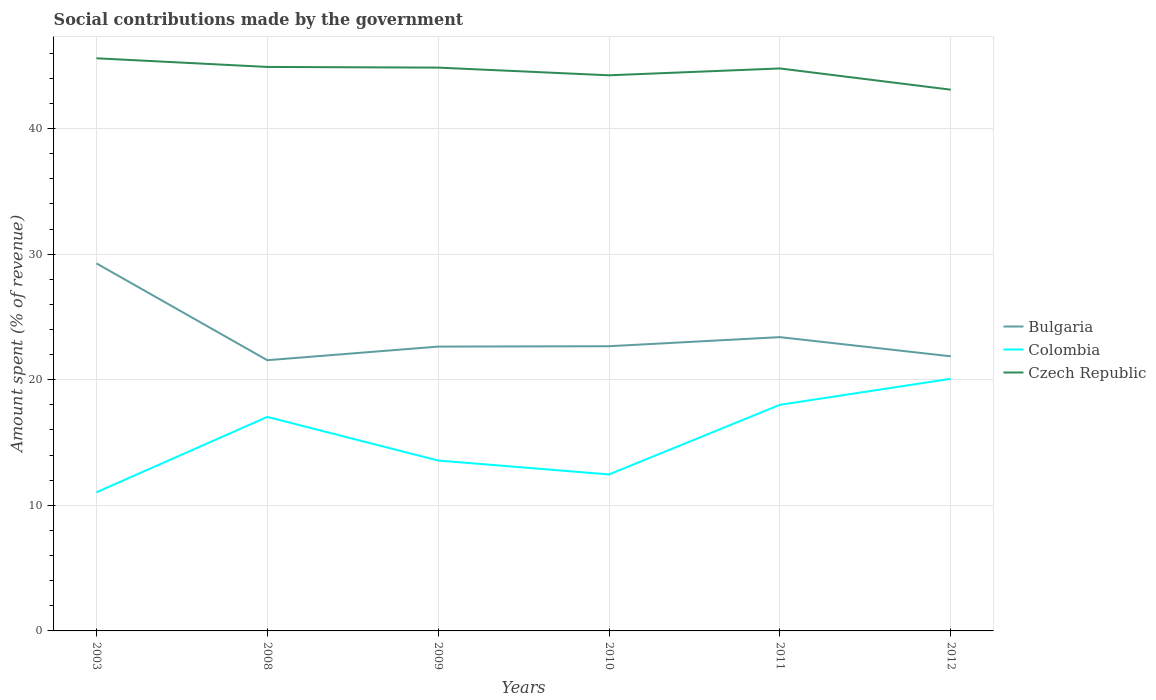Is the number of lines equal to the number of legend labels?
Give a very brief answer. Yes. Across all years, what is the maximum amount spent (in %) on social contributions in Bulgaria?
Keep it short and to the point. 21.56. What is the total amount spent (in %) on social contributions in Czech Republic in the graph?
Your answer should be very brief. 0.07. What is the difference between the highest and the second highest amount spent (in %) on social contributions in Colombia?
Provide a short and direct response. 9.04. What is the difference between the highest and the lowest amount spent (in %) on social contributions in Colombia?
Offer a very short reply. 3. What is the difference between two consecutive major ticks on the Y-axis?
Your response must be concise. 10. Where does the legend appear in the graph?
Provide a succinct answer. Center right. What is the title of the graph?
Your answer should be compact. Social contributions made by the government. What is the label or title of the X-axis?
Offer a terse response. Years. What is the label or title of the Y-axis?
Provide a succinct answer. Amount spent (% of revenue). What is the Amount spent (% of revenue) in Bulgaria in 2003?
Keep it short and to the point. 29.27. What is the Amount spent (% of revenue) in Colombia in 2003?
Keep it short and to the point. 11.04. What is the Amount spent (% of revenue) in Czech Republic in 2003?
Offer a terse response. 45.6. What is the Amount spent (% of revenue) in Bulgaria in 2008?
Provide a succinct answer. 21.56. What is the Amount spent (% of revenue) of Colombia in 2008?
Ensure brevity in your answer.  17.04. What is the Amount spent (% of revenue) of Czech Republic in 2008?
Offer a terse response. 44.91. What is the Amount spent (% of revenue) in Bulgaria in 2009?
Your response must be concise. 22.64. What is the Amount spent (% of revenue) in Colombia in 2009?
Your answer should be very brief. 13.57. What is the Amount spent (% of revenue) in Czech Republic in 2009?
Offer a terse response. 44.85. What is the Amount spent (% of revenue) of Bulgaria in 2010?
Your answer should be compact. 22.67. What is the Amount spent (% of revenue) of Colombia in 2010?
Ensure brevity in your answer.  12.46. What is the Amount spent (% of revenue) in Czech Republic in 2010?
Offer a very short reply. 44.24. What is the Amount spent (% of revenue) of Bulgaria in 2011?
Make the answer very short. 23.39. What is the Amount spent (% of revenue) of Colombia in 2011?
Provide a succinct answer. 18. What is the Amount spent (% of revenue) of Czech Republic in 2011?
Keep it short and to the point. 44.79. What is the Amount spent (% of revenue) in Bulgaria in 2012?
Offer a terse response. 21.87. What is the Amount spent (% of revenue) of Colombia in 2012?
Give a very brief answer. 20.08. What is the Amount spent (% of revenue) of Czech Republic in 2012?
Give a very brief answer. 43.1. Across all years, what is the maximum Amount spent (% of revenue) in Bulgaria?
Provide a short and direct response. 29.27. Across all years, what is the maximum Amount spent (% of revenue) of Colombia?
Your response must be concise. 20.08. Across all years, what is the maximum Amount spent (% of revenue) in Czech Republic?
Give a very brief answer. 45.6. Across all years, what is the minimum Amount spent (% of revenue) in Bulgaria?
Make the answer very short. 21.56. Across all years, what is the minimum Amount spent (% of revenue) of Colombia?
Offer a very short reply. 11.04. Across all years, what is the minimum Amount spent (% of revenue) of Czech Republic?
Make the answer very short. 43.1. What is the total Amount spent (% of revenue) in Bulgaria in the graph?
Your answer should be very brief. 141.39. What is the total Amount spent (% of revenue) of Colombia in the graph?
Your answer should be compact. 92.18. What is the total Amount spent (% of revenue) in Czech Republic in the graph?
Your answer should be very brief. 267.47. What is the difference between the Amount spent (% of revenue) of Bulgaria in 2003 and that in 2008?
Provide a short and direct response. 7.71. What is the difference between the Amount spent (% of revenue) of Colombia in 2003 and that in 2008?
Your answer should be very brief. -6. What is the difference between the Amount spent (% of revenue) of Czech Republic in 2003 and that in 2008?
Give a very brief answer. 0.69. What is the difference between the Amount spent (% of revenue) in Bulgaria in 2003 and that in 2009?
Offer a very short reply. 6.63. What is the difference between the Amount spent (% of revenue) in Colombia in 2003 and that in 2009?
Ensure brevity in your answer.  -2.53. What is the difference between the Amount spent (% of revenue) in Czech Republic in 2003 and that in 2009?
Your response must be concise. 0.74. What is the difference between the Amount spent (% of revenue) in Bulgaria in 2003 and that in 2010?
Keep it short and to the point. 6.6. What is the difference between the Amount spent (% of revenue) in Colombia in 2003 and that in 2010?
Your response must be concise. -1.42. What is the difference between the Amount spent (% of revenue) in Czech Republic in 2003 and that in 2010?
Make the answer very short. 1.35. What is the difference between the Amount spent (% of revenue) in Bulgaria in 2003 and that in 2011?
Offer a very short reply. 5.87. What is the difference between the Amount spent (% of revenue) of Colombia in 2003 and that in 2011?
Provide a short and direct response. -6.97. What is the difference between the Amount spent (% of revenue) of Czech Republic in 2003 and that in 2011?
Your response must be concise. 0.81. What is the difference between the Amount spent (% of revenue) in Bulgaria in 2003 and that in 2012?
Your answer should be very brief. 7.4. What is the difference between the Amount spent (% of revenue) in Colombia in 2003 and that in 2012?
Give a very brief answer. -9.04. What is the difference between the Amount spent (% of revenue) in Czech Republic in 2003 and that in 2012?
Your answer should be very brief. 2.5. What is the difference between the Amount spent (% of revenue) in Bulgaria in 2008 and that in 2009?
Keep it short and to the point. -1.08. What is the difference between the Amount spent (% of revenue) of Colombia in 2008 and that in 2009?
Ensure brevity in your answer.  3.47. What is the difference between the Amount spent (% of revenue) of Czech Republic in 2008 and that in 2009?
Your answer should be very brief. 0.05. What is the difference between the Amount spent (% of revenue) in Bulgaria in 2008 and that in 2010?
Provide a succinct answer. -1.11. What is the difference between the Amount spent (% of revenue) in Colombia in 2008 and that in 2010?
Provide a succinct answer. 4.58. What is the difference between the Amount spent (% of revenue) in Czech Republic in 2008 and that in 2010?
Offer a terse response. 0.67. What is the difference between the Amount spent (% of revenue) in Bulgaria in 2008 and that in 2011?
Provide a short and direct response. -1.84. What is the difference between the Amount spent (% of revenue) of Colombia in 2008 and that in 2011?
Provide a succinct answer. -0.96. What is the difference between the Amount spent (% of revenue) of Czech Republic in 2008 and that in 2011?
Offer a terse response. 0.12. What is the difference between the Amount spent (% of revenue) of Bulgaria in 2008 and that in 2012?
Offer a very short reply. -0.31. What is the difference between the Amount spent (% of revenue) of Colombia in 2008 and that in 2012?
Provide a succinct answer. -3.04. What is the difference between the Amount spent (% of revenue) of Czech Republic in 2008 and that in 2012?
Give a very brief answer. 1.81. What is the difference between the Amount spent (% of revenue) in Bulgaria in 2009 and that in 2010?
Provide a succinct answer. -0.03. What is the difference between the Amount spent (% of revenue) in Colombia in 2009 and that in 2010?
Make the answer very short. 1.11. What is the difference between the Amount spent (% of revenue) in Czech Republic in 2009 and that in 2010?
Give a very brief answer. 0.61. What is the difference between the Amount spent (% of revenue) in Bulgaria in 2009 and that in 2011?
Offer a very short reply. -0.75. What is the difference between the Amount spent (% of revenue) of Colombia in 2009 and that in 2011?
Offer a very short reply. -4.44. What is the difference between the Amount spent (% of revenue) of Czech Republic in 2009 and that in 2011?
Offer a terse response. 0.07. What is the difference between the Amount spent (% of revenue) in Bulgaria in 2009 and that in 2012?
Your answer should be very brief. 0.77. What is the difference between the Amount spent (% of revenue) in Colombia in 2009 and that in 2012?
Keep it short and to the point. -6.51. What is the difference between the Amount spent (% of revenue) of Czech Republic in 2009 and that in 2012?
Keep it short and to the point. 1.76. What is the difference between the Amount spent (% of revenue) in Bulgaria in 2010 and that in 2011?
Keep it short and to the point. -0.72. What is the difference between the Amount spent (% of revenue) in Colombia in 2010 and that in 2011?
Your response must be concise. -5.54. What is the difference between the Amount spent (% of revenue) in Czech Republic in 2010 and that in 2011?
Ensure brevity in your answer.  -0.54. What is the difference between the Amount spent (% of revenue) of Bulgaria in 2010 and that in 2012?
Provide a succinct answer. 0.8. What is the difference between the Amount spent (% of revenue) of Colombia in 2010 and that in 2012?
Provide a short and direct response. -7.62. What is the difference between the Amount spent (% of revenue) of Czech Republic in 2010 and that in 2012?
Keep it short and to the point. 1.15. What is the difference between the Amount spent (% of revenue) of Bulgaria in 2011 and that in 2012?
Offer a very short reply. 1.53. What is the difference between the Amount spent (% of revenue) in Colombia in 2011 and that in 2012?
Give a very brief answer. -2.07. What is the difference between the Amount spent (% of revenue) in Czech Republic in 2011 and that in 2012?
Offer a very short reply. 1.69. What is the difference between the Amount spent (% of revenue) in Bulgaria in 2003 and the Amount spent (% of revenue) in Colombia in 2008?
Provide a short and direct response. 12.23. What is the difference between the Amount spent (% of revenue) of Bulgaria in 2003 and the Amount spent (% of revenue) of Czech Republic in 2008?
Your response must be concise. -15.64. What is the difference between the Amount spent (% of revenue) of Colombia in 2003 and the Amount spent (% of revenue) of Czech Republic in 2008?
Give a very brief answer. -33.87. What is the difference between the Amount spent (% of revenue) in Bulgaria in 2003 and the Amount spent (% of revenue) in Colombia in 2009?
Offer a terse response. 15.7. What is the difference between the Amount spent (% of revenue) in Bulgaria in 2003 and the Amount spent (% of revenue) in Czech Republic in 2009?
Provide a short and direct response. -15.59. What is the difference between the Amount spent (% of revenue) of Colombia in 2003 and the Amount spent (% of revenue) of Czech Republic in 2009?
Provide a short and direct response. -33.82. What is the difference between the Amount spent (% of revenue) in Bulgaria in 2003 and the Amount spent (% of revenue) in Colombia in 2010?
Provide a short and direct response. 16.81. What is the difference between the Amount spent (% of revenue) in Bulgaria in 2003 and the Amount spent (% of revenue) in Czech Republic in 2010?
Your response must be concise. -14.97. What is the difference between the Amount spent (% of revenue) in Colombia in 2003 and the Amount spent (% of revenue) in Czech Republic in 2010?
Ensure brevity in your answer.  -33.21. What is the difference between the Amount spent (% of revenue) of Bulgaria in 2003 and the Amount spent (% of revenue) of Colombia in 2011?
Offer a terse response. 11.26. What is the difference between the Amount spent (% of revenue) of Bulgaria in 2003 and the Amount spent (% of revenue) of Czech Republic in 2011?
Give a very brief answer. -15.52. What is the difference between the Amount spent (% of revenue) of Colombia in 2003 and the Amount spent (% of revenue) of Czech Republic in 2011?
Offer a very short reply. -33.75. What is the difference between the Amount spent (% of revenue) in Bulgaria in 2003 and the Amount spent (% of revenue) in Colombia in 2012?
Make the answer very short. 9.19. What is the difference between the Amount spent (% of revenue) in Bulgaria in 2003 and the Amount spent (% of revenue) in Czech Republic in 2012?
Offer a terse response. -13.83. What is the difference between the Amount spent (% of revenue) of Colombia in 2003 and the Amount spent (% of revenue) of Czech Republic in 2012?
Provide a succinct answer. -32.06. What is the difference between the Amount spent (% of revenue) in Bulgaria in 2008 and the Amount spent (% of revenue) in Colombia in 2009?
Ensure brevity in your answer.  7.99. What is the difference between the Amount spent (% of revenue) in Bulgaria in 2008 and the Amount spent (% of revenue) in Czech Republic in 2009?
Provide a short and direct response. -23.3. What is the difference between the Amount spent (% of revenue) in Colombia in 2008 and the Amount spent (% of revenue) in Czech Republic in 2009?
Offer a terse response. -27.81. What is the difference between the Amount spent (% of revenue) in Bulgaria in 2008 and the Amount spent (% of revenue) in Colombia in 2010?
Keep it short and to the point. 9.1. What is the difference between the Amount spent (% of revenue) of Bulgaria in 2008 and the Amount spent (% of revenue) of Czech Republic in 2010?
Your response must be concise. -22.69. What is the difference between the Amount spent (% of revenue) in Colombia in 2008 and the Amount spent (% of revenue) in Czech Republic in 2010?
Provide a succinct answer. -27.2. What is the difference between the Amount spent (% of revenue) of Bulgaria in 2008 and the Amount spent (% of revenue) of Colombia in 2011?
Offer a terse response. 3.55. What is the difference between the Amount spent (% of revenue) of Bulgaria in 2008 and the Amount spent (% of revenue) of Czech Republic in 2011?
Your answer should be compact. -23.23. What is the difference between the Amount spent (% of revenue) in Colombia in 2008 and the Amount spent (% of revenue) in Czech Republic in 2011?
Provide a succinct answer. -27.75. What is the difference between the Amount spent (% of revenue) of Bulgaria in 2008 and the Amount spent (% of revenue) of Colombia in 2012?
Make the answer very short. 1.48. What is the difference between the Amount spent (% of revenue) in Bulgaria in 2008 and the Amount spent (% of revenue) in Czech Republic in 2012?
Give a very brief answer. -21.54. What is the difference between the Amount spent (% of revenue) of Colombia in 2008 and the Amount spent (% of revenue) of Czech Republic in 2012?
Your response must be concise. -26.06. What is the difference between the Amount spent (% of revenue) in Bulgaria in 2009 and the Amount spent (% of revenue) in Colombia in 2010?
Your answer should be very brief. 10.18. What is the difference between the Amount spent (% of revenue) in Bulgaria in 2009 and the Amount spent (% of revenue) in Czech Republic in 2010?
Your answer should be very brief. -21.6. What is the difference between the Amount spent (% of revenue) in Colombia in 2009 and the Amount spent (% of revenue) in Czech Republic in 2010?
Your answer should be very brief. -30.67. What is the difference between the Amount spent (% of revenue) of Bulgaria in 2009 and the Amount spent (% of revenue) of Colombia in 2011?
Offer a very short reply. 4.64. What is the difference between the Amount spent (% of revenue) of Bulgaria in 2009 and the Amount spent (% of revenue) of Czech Republic in 2011?
Provide a succinct answer. -22.15. What is the difference between the Amount spent (% of revenue) in Colombia in 2009 and the Amount spent (% of revenue) in Czech Republic in 2011?
Your answer should be very brief. -31.22. What is the difference between the Amount spent (% of revenue) in Bulgaria in 2009 and the Amount spent (% of revenue) in Colombia in 2012?
Offer a terse response. 2.56. What is the difference between the Amount spent (% of revenue) of Bulgaria in 2009 and the Amount spent (% of revenue) of Czech Republic in 2012?
Provide a short and direct response. -20.46. What is the difference between the Amount spent (% of revenue) in Colombia in 2009 and the Amount spent (% of revenue) in Czech Republic in 2012?
Make the answer very short. -29.53. What is the difference between the Amount spent (% of revenue) in Bulgaria in 2010 and the Amount spent (% of revenue) in Colombia in 2011?
Your answer should be compact. 4.67. What is the difference between the Amount spent (% of revenue) of Bulgaria in 2010 and the Amount spent (% of revenue) of Czech Republic in 2011?
Ensure brevity in your answer.  -22.12. What is the difference between the Amount spent (% of revenue) in Colombia in 2010 and the Amount spent (% of revenue) in Czech Republic in 2011?
Your answer should be very brief. -32.33. What is the difference between the Amount spent (% of revenue) in Bulgaria in 2010 and the Amount spent (% of revenue) in Colombia in 2012?
Provide a succinct answer. 2.59. What is the difference between the Amount spent (% of revenue) of Bulgaria in 2010 and the Amount spent (% of revenue) of Czech Republic in 2012?
Provide a succinct answer. -20.43. What is the difference between the Amount spent (% of revenue) in Colombia in 2010 and the Amount spent (% of revenue) in Czech Republic in 2012?
Keep it short and to the point. -30.64. What is the difference between the Amount spent (% of revenue) in Bulgaria in 2011 and the Amount spent (% of revenue) in Colombia in 2012?
Offer a terse response. 3.32. What is the difference between the Amount spent (% of revenue) of Bulgaria in 2011 and the Amount spent (% of revenue) of Czech Republic in 2012?
Provide a short and direct response. -19.7. What is the difference between the Amount spent (% of revenue) of Colombia in 2011 and the Amount spent (% of revenue) of Czech Republic in 2012?
Give a very brief answer. -25.09. What is the average Amount spent (% of revenue) of Bulgaria per year?
Offer a very short reply. 23.56. What is the average Amount spent (% of revenue) of Colombia per year?
Give a very brief answer. 15.36. What is the average Amount spent (% of revenue) of Czech Republic per year?
Ensure brevity in your answer.  44.58. In the year 2003, what is the difference between the Amount spent (% of revenue) of Bulgaria and Amount spent (% of revenue) of Colombia?
Provide a short and direct response. 18.23. In the year 2003, what is the difference between the Amount spent (% of revenue) of Bulgaria and Amount spent (% of revenue) of Czech Republic?
Keep it short and to the point. -16.33. In the year 2003, what is the difference between the Amount spent (% of revenue) in Colombia and Amount spent (% of revenue) in Czech Republic?
Keep it short and to the point. -34.56. In the year 2008, what is the difference between the Amount spent (% of revenue) in Bulgaria and Amount spent (% of revenue) in Colombia?
Your answer should be compact. 4.52. In the year 2008, what is the difference between the Amount spent (% of revenue) in Bulgaria and Amount spent (% of revenue) in Czech Republic?
Your answer should be compact. -23.35. In the year 2008, what is the difference between the Amount spent (% of revenue) in Colombia and Amount spent (% of revenue) in Czech Republic?
Ensure brevity in your answer.  -27.87. In the year 2009, what is the difference between the Amount spent (% of revenue) in Bulgaria and Amount spent (% of revenue) in Colombia?
Your answer should be very brief. 9.07. In the year 2009, what is the difference between the Amount spent (% of revenue) in Bulgaria and Amount spent (% of revenue) in Czech Republic?
Your answer should be very brief. -22.21. In the year 2009, what is the difference between the Amount spent (% of revenue) in Colombia and Amount spent (% of revenue) in Czech Republic?
Make the answer very short. -31.29. In the year 2010, what is the difference between the Amount spent (% of revenue) of Bulgaria and Amount spent (% of revenue) of Colombia?
Offer a very short reply. 10.21. In the year 2010, what is the difference between the Amount spent (% of revenue) in Bulgaria and Amount spent (% of revenue) in Czech Republic?
Provide a short and direct response. -21.57. In the year 2010, what is the difference between the Amount spent (% of revenue) of Colombia and Amount spent (% of revenue) of Czech Republic?
Ensure brevity in your answer.  -31.78. In the year 2011, what is the difference between the Amount spent (% of revenue) in Bulgaria and Amount spent (% of revenue) in Colombia?
Offer a very short reply. 5.39. In the year 2011, what is the difference between the Amount spent (% of revenue) in Bulgaria and Amount spent (% of revenue) in Czech Republic?
Your answer should be very brief. -21.39. In the year 2011, what is the difference between the Amount spent (% of revenue) in Colombia and Amount spent (% of revenue) in Czech Republic?
Your answer should be compact. -26.78. In the year 2012, what is the difference between the Amount spent (% of revenue) in Bulgaria and Amount spent (% of revenue) in Colombia?
Ensure brevity in your answer.  1.79. In the year 2012, what is the difference between the Amount spent (% of revenue) of Bulgaria and Amount spent (% of revenue) of Czech Republic?
Your answer should be compact. -21.23. In the year 2012, what is the difference between the Amount spent (% of revenue) of Colombia and Amount spent (% of revenue) of Czech Republic?
Keep it short and to the point. -23.02. What is the ratio of the Amount spent (% of revenue) of Bulgaria in 2003 to that in 2008?
Offer a terse response. 1.36. What is the ratio of the Amount spent (% of revenue) of Colombia in 2003 to that in 2008?
Give a very brief answer. 0.65. What is the ratio of the Amount spent (% of revenue) of Czech Republic in 2003 to that in 2008?
Offer a very short reply. 1.02. What is the ratio of the Amount spent (% of revenue) in Bulgaria in 2003 to that in 2009?
Give a very brief answer. 1.29. What is the ratio of the Amount spent (% of revenue) in Colombia in 2003 to that in 2009?
Your answer should be very brief. 0.81. What is the ratio of the Amount spent (% of revenue) of Czech Republic in 2003 to that in 2009?
Make the answer very short. 1.02. What is the ratio of the Amount spent (% of revenue) in Bulgaria in 2003 to that in 2010?
Your answer should be very brief. 1.29. What is the ratio of the Amount spent (% of revenue) in Colombia in 2003 to that in 2010?
Provide a short and direct response. 0.89. What is the ratio of the Amount spent (% of revenue) of Czech Republic in 2003 to that in 2010?
Your answer should be very brief. 1.03. What is the ratio of the Amount spent (% of revenue) of Bulgaria in 2003 to that in 2011?
Your response must be concise. 1.25. What is the ratio of the Amount spent (% of revenue) of Colombia in 2003 to that in 2011?
Give a very brief answer. 0.61. What is the ratio of the Amount spent (% of revenue) of Czech Republic in 2003 to that in 2011?
Make the answer very short. 1.02. What is the ratio of the Amount spent (% of revenue) of Bulgaria in 2003 to that in 2012?
Provide a succinct answer. 1.34. What is the ratio of the Amount spent (% of revenue) in Colombia in 2003 to that in 2012?
Your response must be concise. 0.55. What is the ratio of the Amount spent (% of revenue) in Czech Republic in 2003 to that in 2012?
Give a very brief answer. 1.06. What is the ratio of the Amount spent (% of revenue) of Bulgaria in 2008 to that in 2009?
Offer a terse response. 0.95. What is the ratio of the Amount spent (% of revenue) in Colombia in 2008 to that in 2009?
Provide a short and direct response. 1.26. What is the ratio of the Amount spent (% of revenue) of Czech Republic in 2008 to that in 2009?
Your answer should be very brief. 1. What is the ratio of the Amount spent (% of revenue) in Bulgaria in 2008 to that in 2010?
Your response must be concise. 0.95. What is the ratio of the Amount spent (% of revenue) of Colombia in 2008 to that in 2010?
Make the answer very short. 1.37. What is the ratio of the Amount spent (% of revenue) of Bulgaria in 2008 to that in 2011?
Make the answer very short. 0.92. What is the ratio of the Amount spent (% of revenue) in Colombia in 2008 to that in 2011?
Keep it short and to the point. 0.95. What is the ratio of the Amount spent (% of revenue) of Bulgaria in 2008 to that in 2012?
Keep it short and to the point. 0.99. What is the ratio of the Amount spent (% of revenue) of Colombia in 2008 to that in 2012?
Your response must be concise. 0.85. What is the ratio of the Amount spent (% of revenue) in Czech Republic in 2008 to that in 2012?
Make the answer very short. 1.04. What is the ratio of the Amount spent (% of revenue) in Bulgaria in 2009 to that in 2010?
Offer a very short reply. 1. What is the ratio of the Amount spent (% of revenue) of Colombia in 2009 to that in 2010?
Your answer should be very brief. 1.09. What is the ratio of the Amount spent (% of revenue) of Czech Republic in 2009 to that in 2010?
Provide a short and direct response. 1.01. What is the ratio of the Amount spent (% of revenue) in Bulgaria in 2009 to that in 2011?
Provide a short and direct response. 0.97. What is the ratio of the Amount spent (% of revenue) of Colombia in 2009 to that in 2011?
Offer a terse response. 0.75. What is the ratio of the Amount spent (% of revenue) in Czech Republic in 2009 to that in 2011?
Your answer should be compact. 1. What is the ratio of the Amount spent (% of revenue) in Bulgaria in 2009 to that in 2012?
Ensure brevity in your answer.  1.04. What is the ratio of the Amount spent (% of revenue) of Colombia in 2009 to that in 2012?
Make the answer very short. 0.68. What is the ratio of the Amount spent (% of revenue) of Czech Republic in 2009 to that in 2012?
Offer a very short reply. 1.04. What is the ratio of the Amount spent (% of revenue) of Colombia in 2010 to that in 2011?
Your answer should be very brief. 0.69. What is the ratio of the Amount spent (% of revenue) in Czech Republic in 2010 to that in 2011?
Your answer should be compact. 0.99. What is the ratio of the Amount spent (% of revenue) in Bulgaria in 2010 to that in 2012?
Ensure brevity in your answer.  1.04. What is the ratio of the Amount spent (% of revenue) of Colombia in 2010 to that in 2012?
Your answer should be very brief. 0.62. What is the ratio of the Amount spent (% of revenue) in Czech Republic in 2010 to that in 2012?
Your answer should be very brief. 1.03. What is the ratio of the Amount spent (% of revenue) in Bulgaria in 2011 to that in 2012?
Your answer should be very brief. 1.07. What is the ratio of the Amount spent (% of revenue) in Colombia in 2011 to that in 2012?
Offer a terse response. 0.9. What is the ratio of the Amount spent (% of revenue) of Czech Republic in 2011 to that in 2012?
Your response must be concise. 1.04. What is the difference between the highest and the second highest Amount spent (% of revenue) in Bulgaria?
Your response must be concise. 5.87. What is the difference between the highest and the second highest Amount spent (% of revenue) of Colombia?
Offer a very short reply. 2.07. What is the difference between the highest and the second highest Amount spent (% of revenue) of Czech Republic?
Provide a succinct answer. 0.69. What is the difference between the highest and the lowest Amount spent (% of revenue) of Bulgaria?
Make the answer very short. 7.71. What is the difference between the highest and the lowest Amount spent (% of revenue) of Colombia?
Provide a succinct answer. 9.04. What is the difference between the highest and the lowest Amount spent (% of revenue) in Czech Republic?
Give a very brief answer. 2.5. 